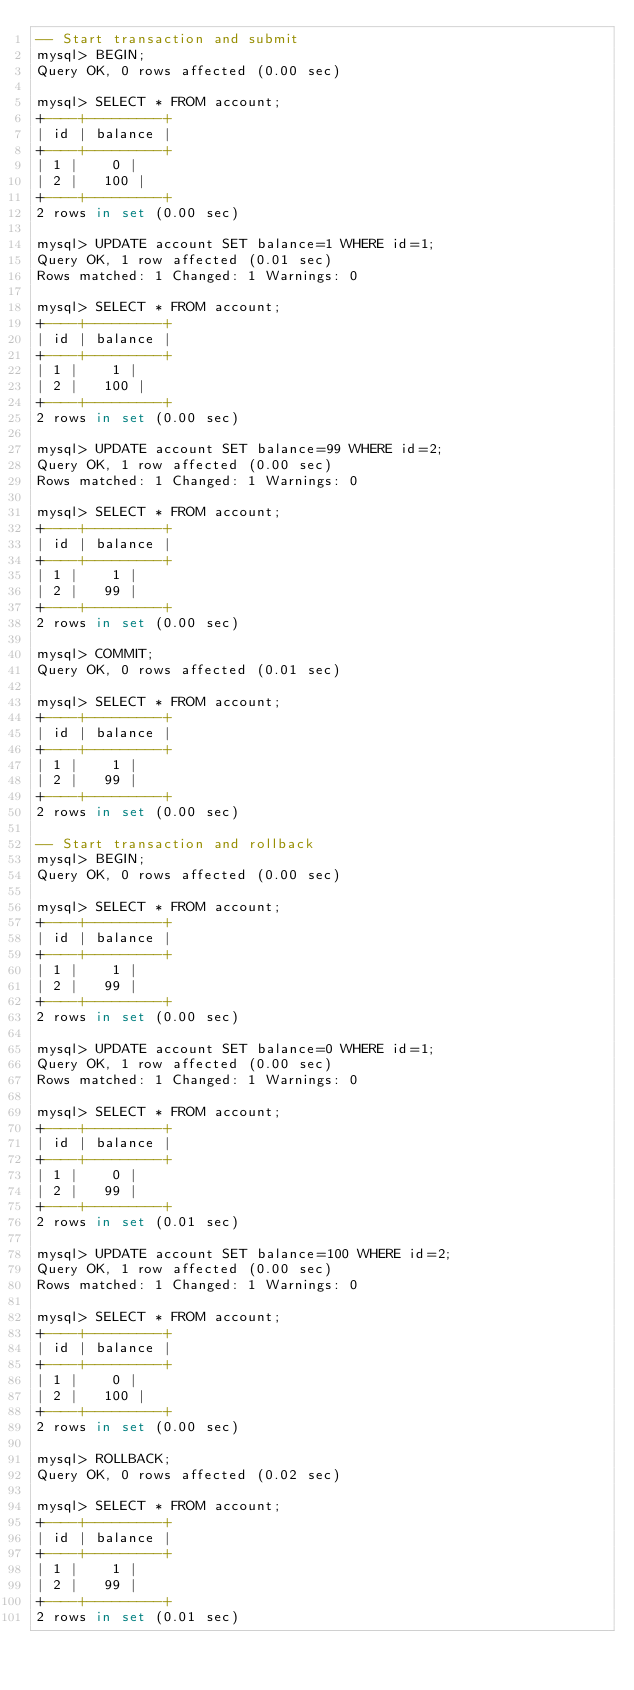Convert code to text. <code><loc_0><loc_0><loc_500><loc_500><_SQL_>-- Start transaction and submit
mysql> BEGIN;
Query OK, 0 rows affected (0.00 sec)

mysql> SELECT * FROM account;
+----+---------+
| id | balance |
+----+---------+
| 1 |    0 |
| 2 |   100 |
+----+---------+
2 rows in set (0.00 sec)

mysql> UPDATE account SET balance=1 WHERE id=1;
Query OK, 1 row affected (0.01 sec)
Rows matched: 1 Changed: 1 Warnings: 0

mysql> SELECT * FROM account;
+----+---------+
| id | balance |
+----+---------+
| 1 |    1 |
| 2 |   100 |
+----+---------+
2 rows in set (0.00 sec)

mysql> UPDATE account SET balance=99 WHERE id=2;
Query OK, 1 row affected (0.00 sec)
Rows matched: 1 Changed: 1 Warnings: 0

mysql> SELECT * FROM account;
+----+---------+
| id | balance |
+----+---------+
| 1 |    1 |
| 2 |   99 |
+----+---------+
2 rows in set (0.00 sec)

mysql> COMMIT;
Query OK, 0 rows affected (0.01 sec)

mysql> SELECT * FROM account;
+----+---------+
| id | balance |
+----+---------+
| 1 |    1 |
| 2 |   99 |
+----+---------+
2 rows in set (0.00 sec)

-- Start transaction and rollback
mysql> BEGIN;
Query OK, 0 rows affected (0.00 sec)

mysql> SELECT * FROM account;
+----+---------+
| id | balance |
+----+---------+
| 1 |    1 |
| 2 |   99 |
+----+---------+
2 rows in set (0.00 sec)

mysql> UPDATE account SET balance=0 WHERE id=1;
Query OK, 1 row affected (0.00 sec)
Rows matched: 1 Changed: 1 Warnings: 0

mysql> SELECT * FROM account;
+----+---------+
| id | balance |
+----+---------+
| 1 |    0 |
| 2 |   99 |
+----+---------+
2 rows in set (0.01 sec)

mysql> UPDATE account SET balance=100 WHERE id=2;
Query OK, 1 row affected (0.00 sec)
Rows matched: 1 Changed: 1 Warnings: 0

mysql> SELECT * FROM account;
+----+---------+
| id | balance |
+----+---------+
| 1 |    0 |
| 2 |   100 |
+----+---------+
2 rows in set (0.00 sec)

mysql> ROLLBACK;
Query OK, 0 rows affected (0.02 sec)

mysql> SELECT * FROM account;
+----+---------+
| id | balance |
+----+---------+
| 1 |    1 |
| 2 |   99 |
+----+---------+
2 rows in set (0.01 sec)
</code> 